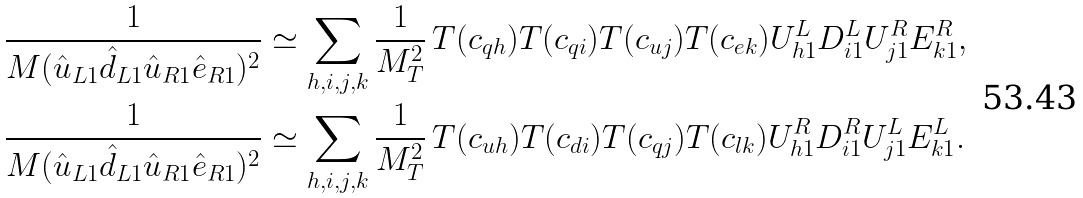<formula> <loc_0><loc_0><loc_500><loc_500>\frac { 1 } { M ( \hat { u } _ { L 1 } \hat { d } _ { L 1 } \hat { u } _ { R 1 } \hat { e } _ { R 1 } ) ^ { 2 } } & \simeq \sum _ { h , i , j , k } \frac { 1 } { M _ { T } ^ { 2 } } \, T ( c _ { q h } ) T ( c _ { q i } ) T ( c _ { u j } ) T ( c _ { e k } ) U ^ { L } _ { h 1 } D ^ { L } _ { i 1 } U ^ { R } _ { j 1 } E ^ { R } _ { k 1 } , \\ \frac { 1 } { M ( \hat { u } _ { L 1 } \hat { d } _ { L 1 } \hat { u } _ { R 1 } \hat { e } _ { R 1 } ) ^ { 2 } } & \simeq \sum _ { h , i , j , k } \frac { 1 } { M _ { T } ^ { 2 } } \, T ( c _ { u h } ) T ( c _ { d i } ) T ( c _ { q j } ) T ( c _ { l k } ) U ^ { R } _ { h 1 } D ^ { R } _ { i 1 } U ^ { L } _ { j 1 } E ^ { L } _ { k 1 } .</formula> 